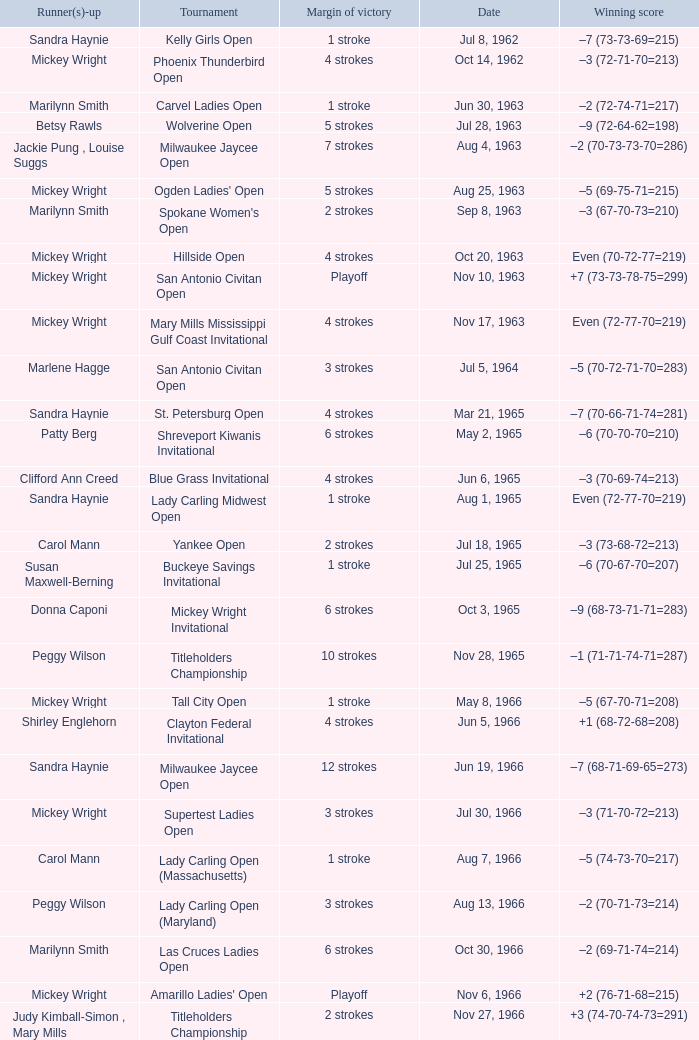What was the margin of victory on Apr 23, 1967? 5 strokes. Could you parse the entire table as a dict? {'header': ['Runner(s)-up', 'Tournament', 'Margin of victory', 'Date', 'Winning score'], 'rows': [['Sandra Haynie', 'Kelly Girls Open', '1 stroke', 'Jul 8, 1962', '–7 (73-73-69=215)'], ['Mickey Wright', 'Phoenix Thunderbird Open', '4 strokes', 'Oct 14, 1962', '–3 (72-71-70=213)'], ['Marilynn Smith', 'Carvel Ladies Open', '1 stroke', 'Jun 30, 1963', '–2 (72-74-71=217)'], ['Betsy Rawls', 'Wolverine Open', '5 strokes', 'Jul 28, 1963', '–9 (72-64-62=198)'], ['Jackie Pung , Louise Suggs', 'Milwaukee Jaycee Open', '7 strokes', 'Aug 4, 1963', '–2 (70-73-73-70=286)'], ['Mickey Wright', "Ogden Ladies' Open", '5 strokes', 'Aug 25, 1963', '–5 (69-75-71=215)'], ['Marilynn Smith', "Spokane Women's Open", '2 strokes', 'Sep 8, 1963', '–3 (67-70-73=210)'], ['Mickey Wright', 'Hillside Open', '4 strokes', 'Oct 20, 1963', 'Even (70-72-77=219)'], ['Mickey Wright', 'San Antonio Civitan Open', 'Playoff', 'Nov 10, 1963', '+7 (73-73-78-75=299)'], ['Mickey Wright', 'Mary Mills Mississippi Gulf Coast Invitational', '4 strokes', 'Nov 17, 1963', 'Even (72-77-70=219)'], ['Marlene Hagge', 'San Antonio Civitan Open', '3 strokes', 'Jul 5, 1964', '–5 (70-72-71-70=283)'], ['Sandra Haynie', 'St. Petersburg Open', '4 strokes', 'Mar 21, 1965', '–7 (70-66-71-74=281)'], ['Patty Berg', 'Shreveport Kiwanis Invitational', '6 strokes', 'May 2, 1965', '–6 (70-70-70=210)'], ['Clifford Ann Creed', 'Blue Grass Invitational', '4 strokes', 'Jun 6, 1965', '–3 (70-69-74=213)'], ['Sandra Haynie', 'Lady Carling Midwest Open', '1 stroke', 'Aug 1, 1965', 'Even (72-77-70=219)'], ['Carol Mann', 'Yankee Open', '2 strokes', 'Jul 18, 1965', '–3 (73-68-72=213)'], ['Susan Maxwell-Berning', 'Buckeye Savings Invitational', '1 stroke', 'Jul 25, 1965', '–6 (70-67-70=207)'], ['Donna Caponi', 'Mickey Wright Invitational', '6 strokes', 'Oct 3, 1965', '–9 (68-73-71-71=283)'], ['Peggy Wilson', 'Titleholders Championship', '10 strokes', 'Nov 28, 1965', '–1 (71-71-74-71=287)'], ['Mickey Wright', 'Tall City Open', '1 stroke', 'May 8, 1966', '–5 (67-70-71=208)'], ['Shirley Englehorn', 'Clayton Federal Invitational', '4 strokes', 'Jun 5, 1966', '+1 (68-72-68=208)'], ['Sandra Haynie', 'Milwaukee Jaycee Open', '12 strokes', 'Jun 19, 1966', '–7 (68-71-69-65=273)'], ['Mickey Wright', 'Supertest Ladies Open', '3 strokes', 'Jul 30, 1966', '–3 (71-70-72=213)'], ['Carol Mann', 'Lady Carling Open (Massachusetts)', '1 stroke', 'Aug 7, 1966', '–5 (74-73-70=217)'], ['Peggy Wilson', 'Lady Carling Open (Maryland)', '3 strokes', 'Aug 13, 1966', '–2 (70-71-73=214)'], ['Marilynn Smith', 'Las Cruces Ladies Open', '6 strokes', 'Oct 30, 1966', '–2 (69-71-74=214)'], ['Mickey Wright', "Amarillo Ladies' Open", 'Playoff', 'Nov 6, 1966', '+2 (76-71-68=215)'], ['Judy Kimball-Simon , Mary Mills', 'Titleholders Championship', '2 strokes', 'Nov 27, 1966', '+3 (74-70-74-73=291)'], ['Clifford Ann Creed , Gloria Ehret', 'Venice Ladies Open', '1 stroke', 'Mar 26, 1967', '+4 (70-71-76=217)'], ['Susie Maxwell Berning', 'Raleigh Ladies Invitational', '5 strokes', 'Apr 23, 1967', '–1 (72-72-71=215)'], ['Carol Mann', "St. Louis Women's Invitational", '2 strokes', 'Jun 7, 1967', '+2 (68-70-71=209)'], ['Shirley Englehorn', 'LPGA Championship', '1 stroke', 'Jul 16, 1967', '–8 (69-74-72-69=284)'], ['Susie Maxwell Berning', 'Lady Carling Open (Ohio)', '1 stroke', 'Aug 6, 1967', '–4 (71-70-71=212)'], ['Sandra Haynie', "Women's Western Open", '3 strokes', 'Aug 20, 1967', '–11 (71-74-73-71=289)'], ['Murle Breer', "Ladies' Los Angeles Open", '4 strokes', 'Oct 1, 1967', '–4 (71-68-73=212)'], ['Sandra Haynie', "Alamo Ladies' Open", '3 strokes', 'Oct 29, 1967', '–3 (71-71-71=213)'], ['Sandra Haynie , Judy Kimball-Simon', 'St. Petersburg Orange Blossom Open', '1 stroke', 'Mar 17, 1968', 'Even (70-71-72=213)'], ['Carol Mann', 'Dallas Civitan Open', '1 stroke', 'May 26, 1968', '–4 (70-70-69=209)'], ['Carol Mann', 'Lady Carling Open (Maryland)', '1 stroke', 'Jun 30, 1968', '–2 (71-70-73=214)'], ['Marlene Hagge', 'Gino Paoli Open', 'Playoff', 'Aug 4, 1968', '–1 (69-72-74=215)'], ['Judy Kimball-Simon , Carol Mann', 'Holiday Inn Classic', '3 strokes', 'Aug 18, 1968', '–1 (74-70-62=206)'], ['Sandra Haynie', 'Kings River Open', '10 strokes', 'Sep 22, 1968', '–8 (68-71-69=208)'], ['Kathy Cornelius', 'River Plantation Invitational', '8 strokes', 'Oct 22, 1968', '–8 (67-70-68=205)'], ['Donna Caponi , Shirley Englehorn , Mary Mills', 'Canyon Ladies Classic', '2 strokes', 'Nov 3, 1968', '+2 (78-69-71=218)'], ['Jo Ann Prentice ,', 'Pensacola Ladies Invitational', '3 strokes', 'Nov 17, 1968', '–3 (71-71-74=216)'], ['Carol Mann', 'Louise Suggs Invitational', '7 strokes', 'Nov 24, 1968', '–8 (69-69-72=210)'], ['Shirley Englehorn , Marlene Hagge', 'Orange Blossom Classic', 'Playoff', 'Mar 17, 1969', '+3 (74-70-72=216)'], ['Sandra Haynie , Sandra Post', 'Port Charlotte Invitational', '1 stroke', 'Mar 23, 1969', '–1 (72-72-74=218)'], ['Mickey Wright', 'Port Malabar Invitational', '4 strokes', 'Mar 30, 1969', '–3 (68-72-70=210)'], ['Mickey Wright', 'Lady Carling Open (Georgia)', 'Playoff', 'Apr 20, 1969', '–4 (70-72-70=212)'], ['Sandra Haynie', 'Patty Berg Classic', '1 stroke', 'Jun 15, 1969', '–5 (69-73-72=214)'], ['Judy Rankin', 'Wendell-West Open', '1 stroke', 'Sep 14, 1969', '–3 (69-72-72=213)'], ['Betsy Rawls', "River Plantation Women's Open", '1 stroke', 'Nov 2, 1969', 'Even (70-71-72=213)'], ['Carol Mann', 'Orange Blossom Classic', '1 stroke', 'Mar 22, 1970', '+3 (73-72-71=216)'], ['JoAnne Carner', "Quality Chek'd Classic", '3 strokes', 'Oct 18, 1970', '–11 (71-67-67=205)'], ['Pam Barnett', 'Raleigh Golf Classic', '5 strokes', 'Apr 18, 1971', '–4 (71-72-69=212)'], ['Sandra Haynie , Sandra Palmer', 'Suzuki Golf Internationale', '2 strokes', 'May 23, 1971', '+1 (72-72-73=217)'], ['Jane Blalock', 'Lady Carling Open', '6 strokes', 'Jun 6, 1971', '–9 (71-68-71=210)'], ['Kathy Ahern', 'Eve-LPGA Championship', '4 strokes', 'Jun 13, 1971', '–4 (71-73-70-74=288)'], ['Mickey Wright', 'Alamo Ladies Open', '3 strokes', 'Apr 30, 1972', '–10 (66-71-72=209)'], ['Marilynn Smith', 'Raleigh Golf Classic', '2 strokes', 'Jul 23, 1972', '–4 (72-69-71=212)'], ['Sandra Haynie', 'Knoxville Ladies Classic', '4 strokes', 'Aug 6, 1972', '–4 (71-68-71=210)'], ['Jocelyne Bourassa', 'Southgate Ladies Open', 'Playoff', 'Aug 20, 1972', 'Even (69-71-76=216)'], ['Sandra Haynie', 'Portland Ladies Open', '4 strokes', 'Oct 1, 1972', '–7 (75-69-68=212)'], ['JoAnne Carner', 'Naples Lely Classic', '2 strokes', 'Feb 11, 1973', '+3 (68-76-75=219)'], ['Mary Mills', 'S&H Green Stamp Classic', '2 strokes', 'Mar 11, 1973', '–2 (73-71-70=214)'], ['Mary Mills', 'Dallas Civitan Open', 'Playoff', 'Sep 9, 1973', '–3 (75-72-66=213)'], ['Gerda Boykin', 'Southgate Ladies Open', '1 stroke', 'Sep 16, 1973', '–2 (72-70=142)'], ['Sandra Palmer', 'Portland Ladies Open', '2 strokes', 'Sep 23, 1973', '–2 (71-73=144)'], ['Kathy Cornelius , Pam Higgins , Marilynn Smith', 'Waco Tribune Herald Ladies Classic', '4 strokes', 'Oct 21, 1973', '–7 (68-72-69=209)'], ['Gloria Ehret , Shelley Hamlin', 'Lady Errol Classic', '2 strokes', 'Nov 4, 1973', '–3 (68-75-70=213)'], ['Sandra Haynie', 'Orange Blossom Classic', '1 stroke', 'Mar 3, 1974', '–7 (70-68-71=209)'], ['Sandra Haynie', 'LPGA Championship', '1 stroke', 'Jun 1, 1975', '–4 (70-70-75-73=288)'], ['Gerda Boykin', 'Southgate Open', '4 strokes', 'Sep 14, 1975', 'Even (72-72-69=213)'], ['Hollis Stacy', 'Bent Tree Classic', '1 stroke', 'Feb 7, 1976', '–7 (69-69-71=209)'], ['Sandra Post', 'Patty Berg Classic', '2 strokes', 'Aug 22, 1976', '–7 (66-73-73=212)'], ['Joanne Carner , Sally Little', "Colgate-Dinah Shore Winner's Circle", '1 stroke', 'Apr 3, 1977', '+1 (76-70-72-71=289)'], ['Pat Bradley', 'American Defender Classic', '1 stroke', 'Apr 24, 1977', '–10 (69-68-69=206)'], ['Donna Caponi', 'LPGA Coca-Cola Classic', '3 strokes', 'May 22, 1977', '–11 (67-68-67=202)'], ['Pat Bradley , Gloria Ehret , JoAnn Washam', 'National Jewish Hospital Open', '3 strokes', 'Sep 10, 1978', '–5 (70-75-66-65=276)'], ['Alice Ritzman', 'Coca-Cola Classic', 'Playoff', 'May 17, 1981', '–8 (69-72-70=211)'], ['Patty Sheehan', "CPC Women's International", '9 strokes', 'Apr 18, 1982', '–7 (73-68-73-67=281)'], ['Sharon Barrett Barbara Moxness', 'Lady Michelob', '4 strokes', 'May 16, 1982', '–9 (69-68-70=207)'], ['Dale Eggeling', "Women's Kemper Open", '1 stroke', 'Mar 20, 1983', '–4 (72-77-70-69=288)'], ['Rosie Jones', 'Rochester International', 'Playoff', 'Jul 22, 1984', '–7 (73-68-71-69=281)'], ['Laura Baugh , Marta Figueras-Dotti', 'Safeco Classic', '2 strokes', 'Sep 16, 1984', '–9 (69-75-65-70=279)'], ['Pat Bradley , Becky Pearson', 'Smirnoff Ladies Irish Open', '2 strokes', 'Oct 14, 1984', '–3 (70-74-69-72=285)'], ['Amy Alcott', 'United Virginia Bank Classic', '1 stroke', 'May 12, 1985', '–9 (69-66-72=207)']]} 